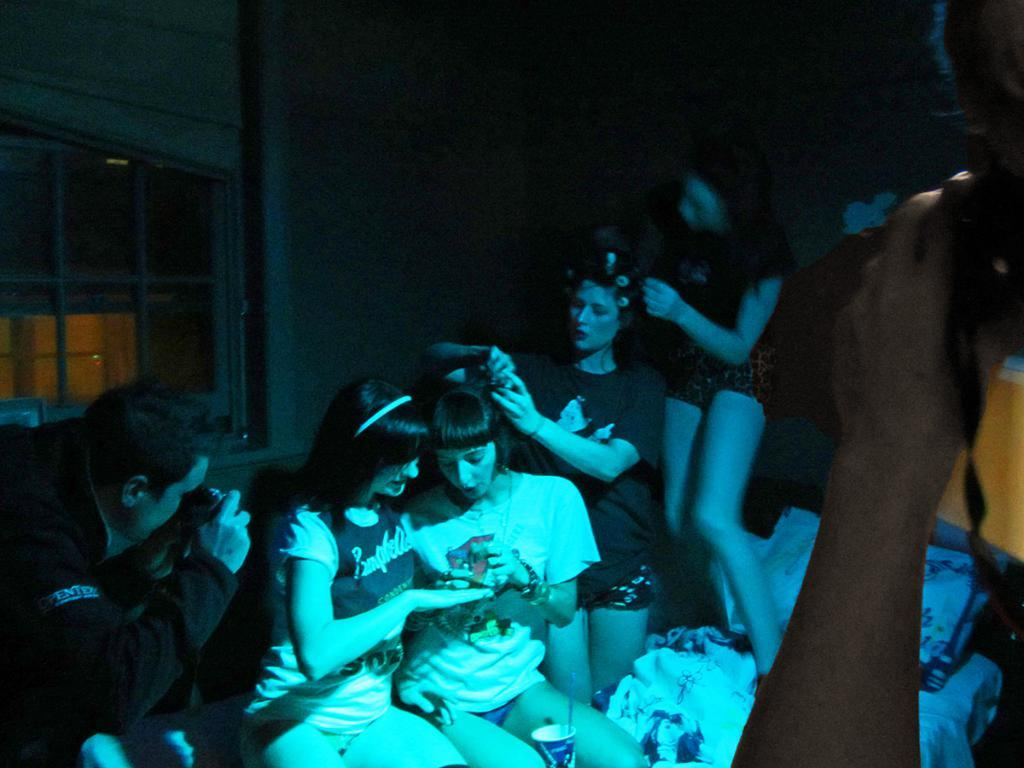How many people are in the image? There is a group of people in the image. What are the people in the image doing? Some people are seated, while others are standing. Can you describe the man on the left side of the image? The man on the left side of the image is holding a camera. What type of brush is being used by the people in the image? There is no brush visible in the image; the people are either seated or standing. 